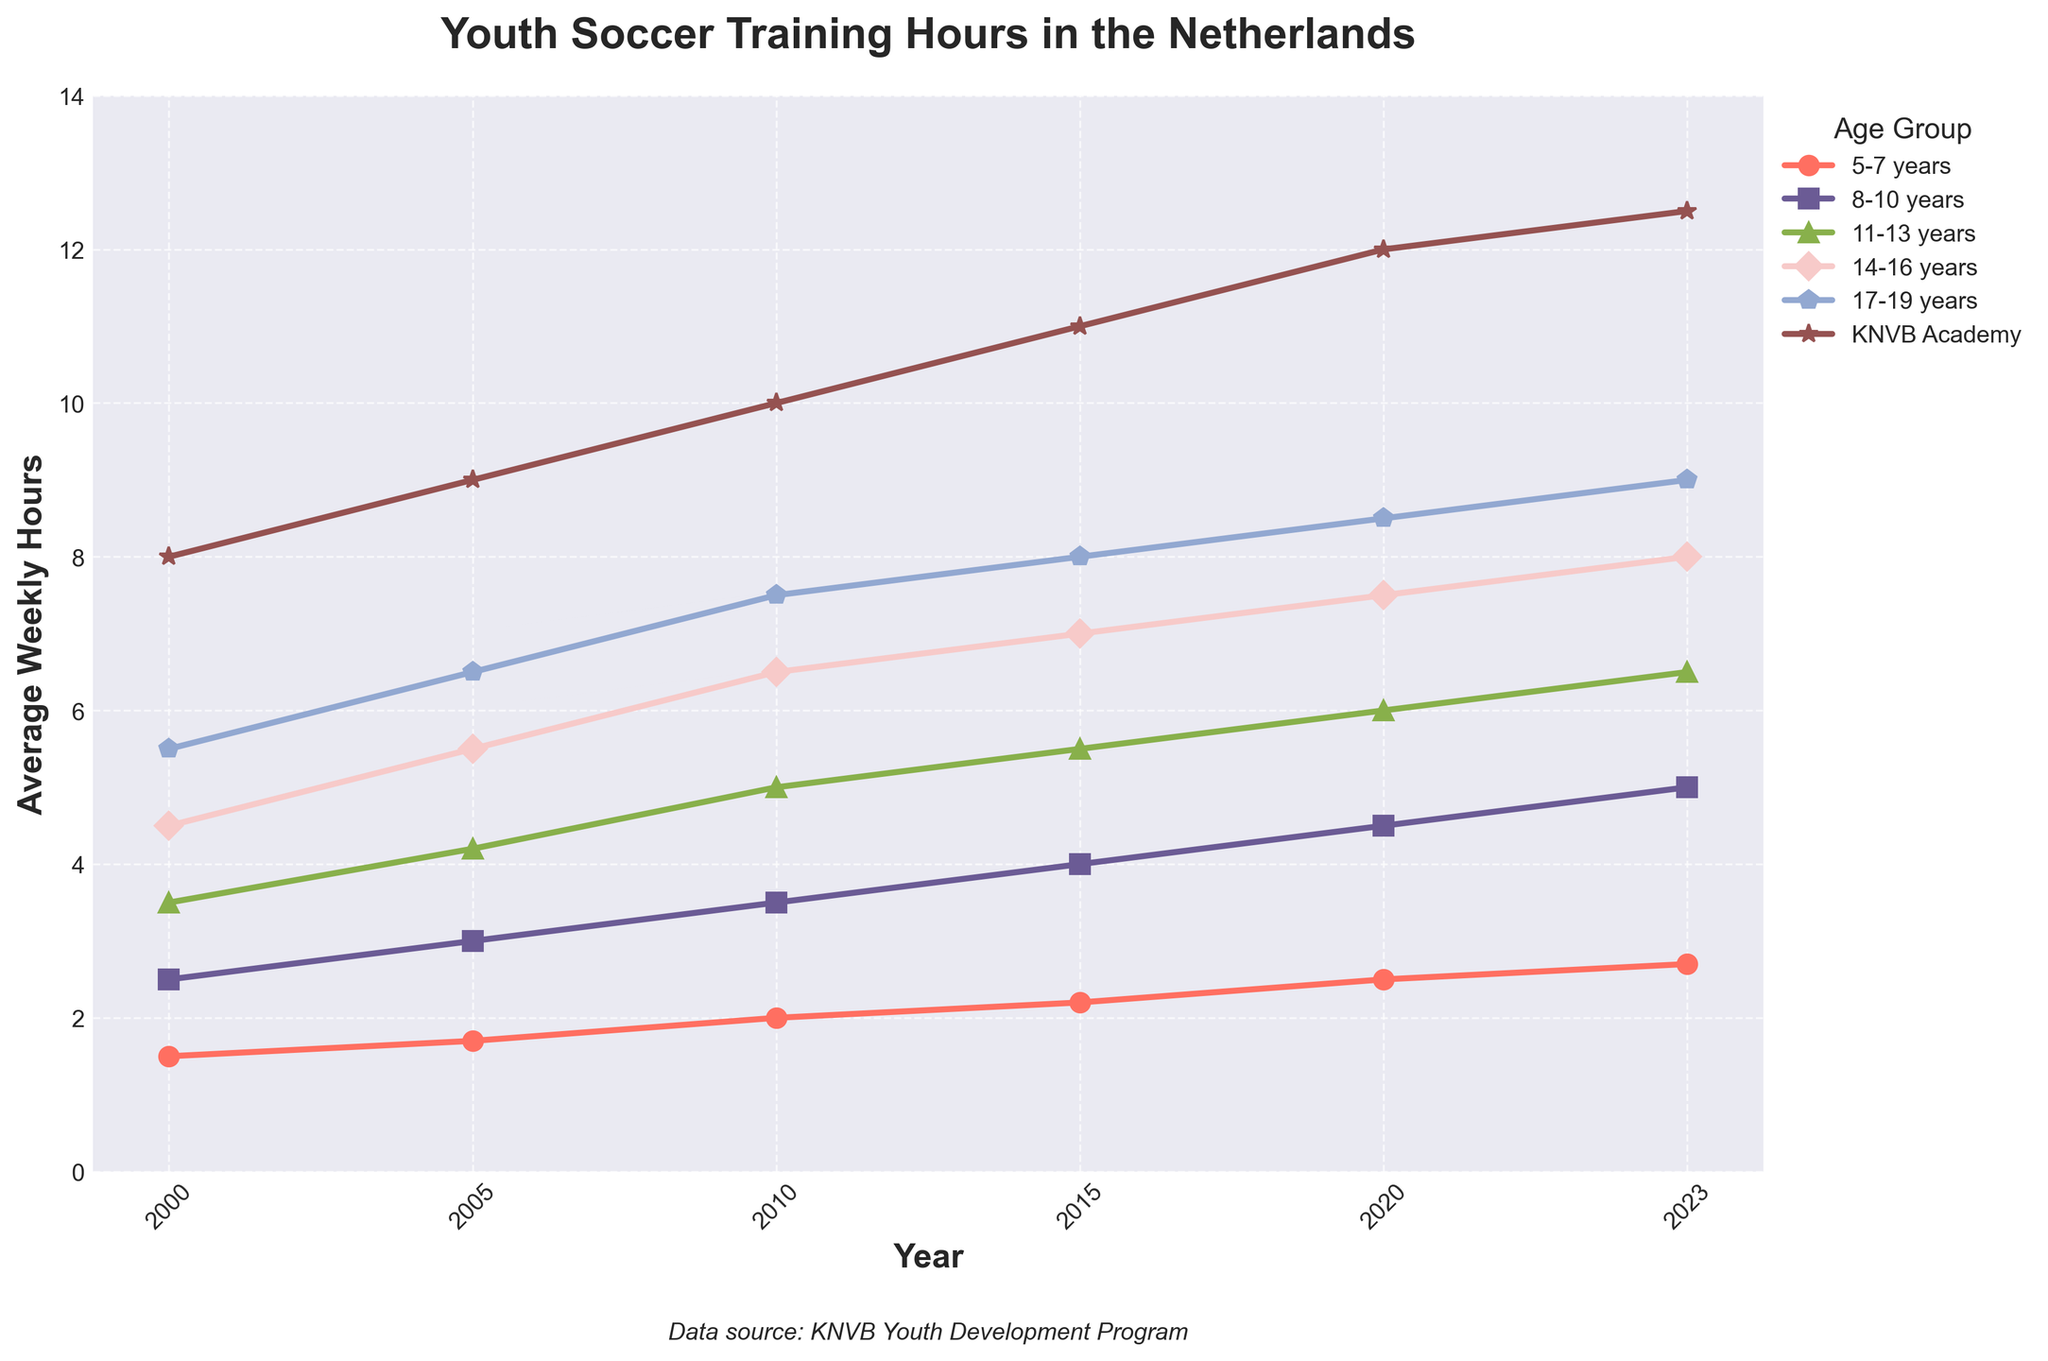What's the trend in soccer training hours for the 14-16 years age group from 2000 to 2023? To identify the trend, observe the plotted line for the 14-16 years age group. The line consistently rises from 4.5 hours in 2000 to 8.0 hours in 2023, indicating an upward trend.
Answer: Upward trend Which age group saw the largest increase in weekly training hours from 2000 to 2023? Compare the start (2000) and end (2023) values of all age groups. The KNVB Academy increased from 8.0 to 12.5 hours, a total increase of 4.5 hours. This is the highest increase among all groups.
Answer: KNVB Academy Between which two consecutive years did the 8-10 years age group experience the highest increase in weekly training hours? Examine the increments between each consecutive year for the 8-10 years age group. The highest change is between 2010 (3.5 hours) and 2015 (4.0 hours), with an increase of 0.5 hours.
Answer: 2010 and 2015 What is the average weekly training hours for the 5-7 years age group over the recorded time period? Sum all the weekly training hours for 5-7 years (1.5 + 1.7 + 2.0 + 2.2 + 2.5 + 2.7) which equals 12.6, and then divide by the number of years (6).
Answer: 2.1 hours Which age group's training hours surpassed 5 hours first, and in which year did that happen? Look at the data for when each age group first exceeded 5 hours. The 14-16 years age group first surpassed 5 hours in 2005.
Answer: 14-16 years, 2005 Are the differences in training hours between adjacent age groups consistent in 2023? Compare the differences in 2023 values: 5-7 years (2.7) to 8-10 years (5.0) is 2.3; 8-10 years (5.0) to 11-13 years (6.5) is 1.5; 11-13 years (6.5) to 14-16 years (8.0) is 1.5; 14-16 years (8.0) and 17-19 years (9.0) is 1.0. The differences are not consistent.
Answer: No Which age group consistently showed the steepest rise in training hours from 2000 to 2023? Observe the steepness of trends for all age groups throughout the period. The KNVB Academy line shows the steepest continuous rise from 8.0 to 12.5 hours.
Answer: KNVB Academy 